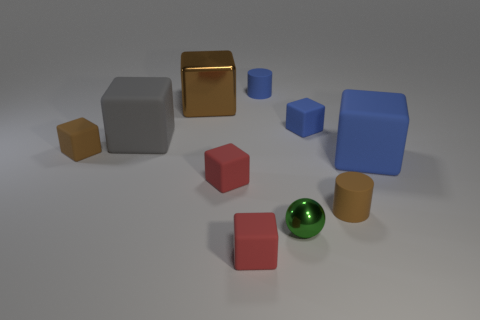What color is the tiny shiny object?
Give a very brief answer. Green. There is a metal thing that is in front of the large gray rubber object; does it have the same size as the red object in front of the small metal sphere?
Give a very brief answer. Yes. Are there fewer tiny blocks than tiny green rubber things?
Give a very brief answer. No. What number of small spheres are in front of the green metallic sphere?
Your answer should be very brief. 0. What is the material of the big gray thing?
Ensure brevity in your answer.  Rubber. Are there fewer green metallic objects behind the sphere than tiny blue things?
Keep it short and to the point. Yes. There is a tiny cylinder to the left of the shiny sphere; what is its color?
Your answer should be compact. Blue. There is a large brown shiny object; what shape is it?
Make the answer very short. Cube. There is a large thing that is right of the small blue thing that is left of the small green ball; is there a brown cylinder in front of it?
Ensure brevity in your answer.  Yes. There is a large rubber thing that is right of the small cylinder behind the large blue matte cube that is right of the blue cylinder; what color is it?
Your answer should be compact. Blue. 